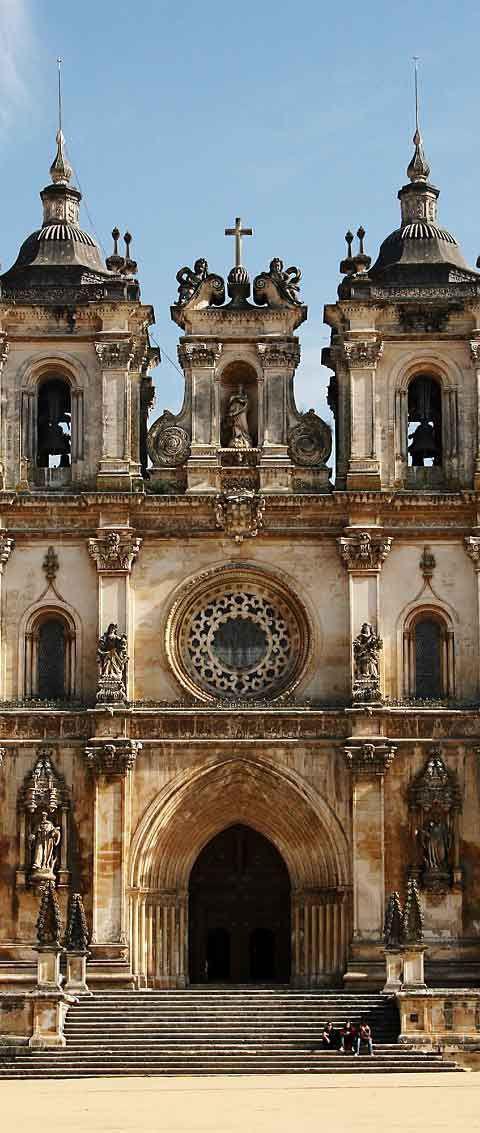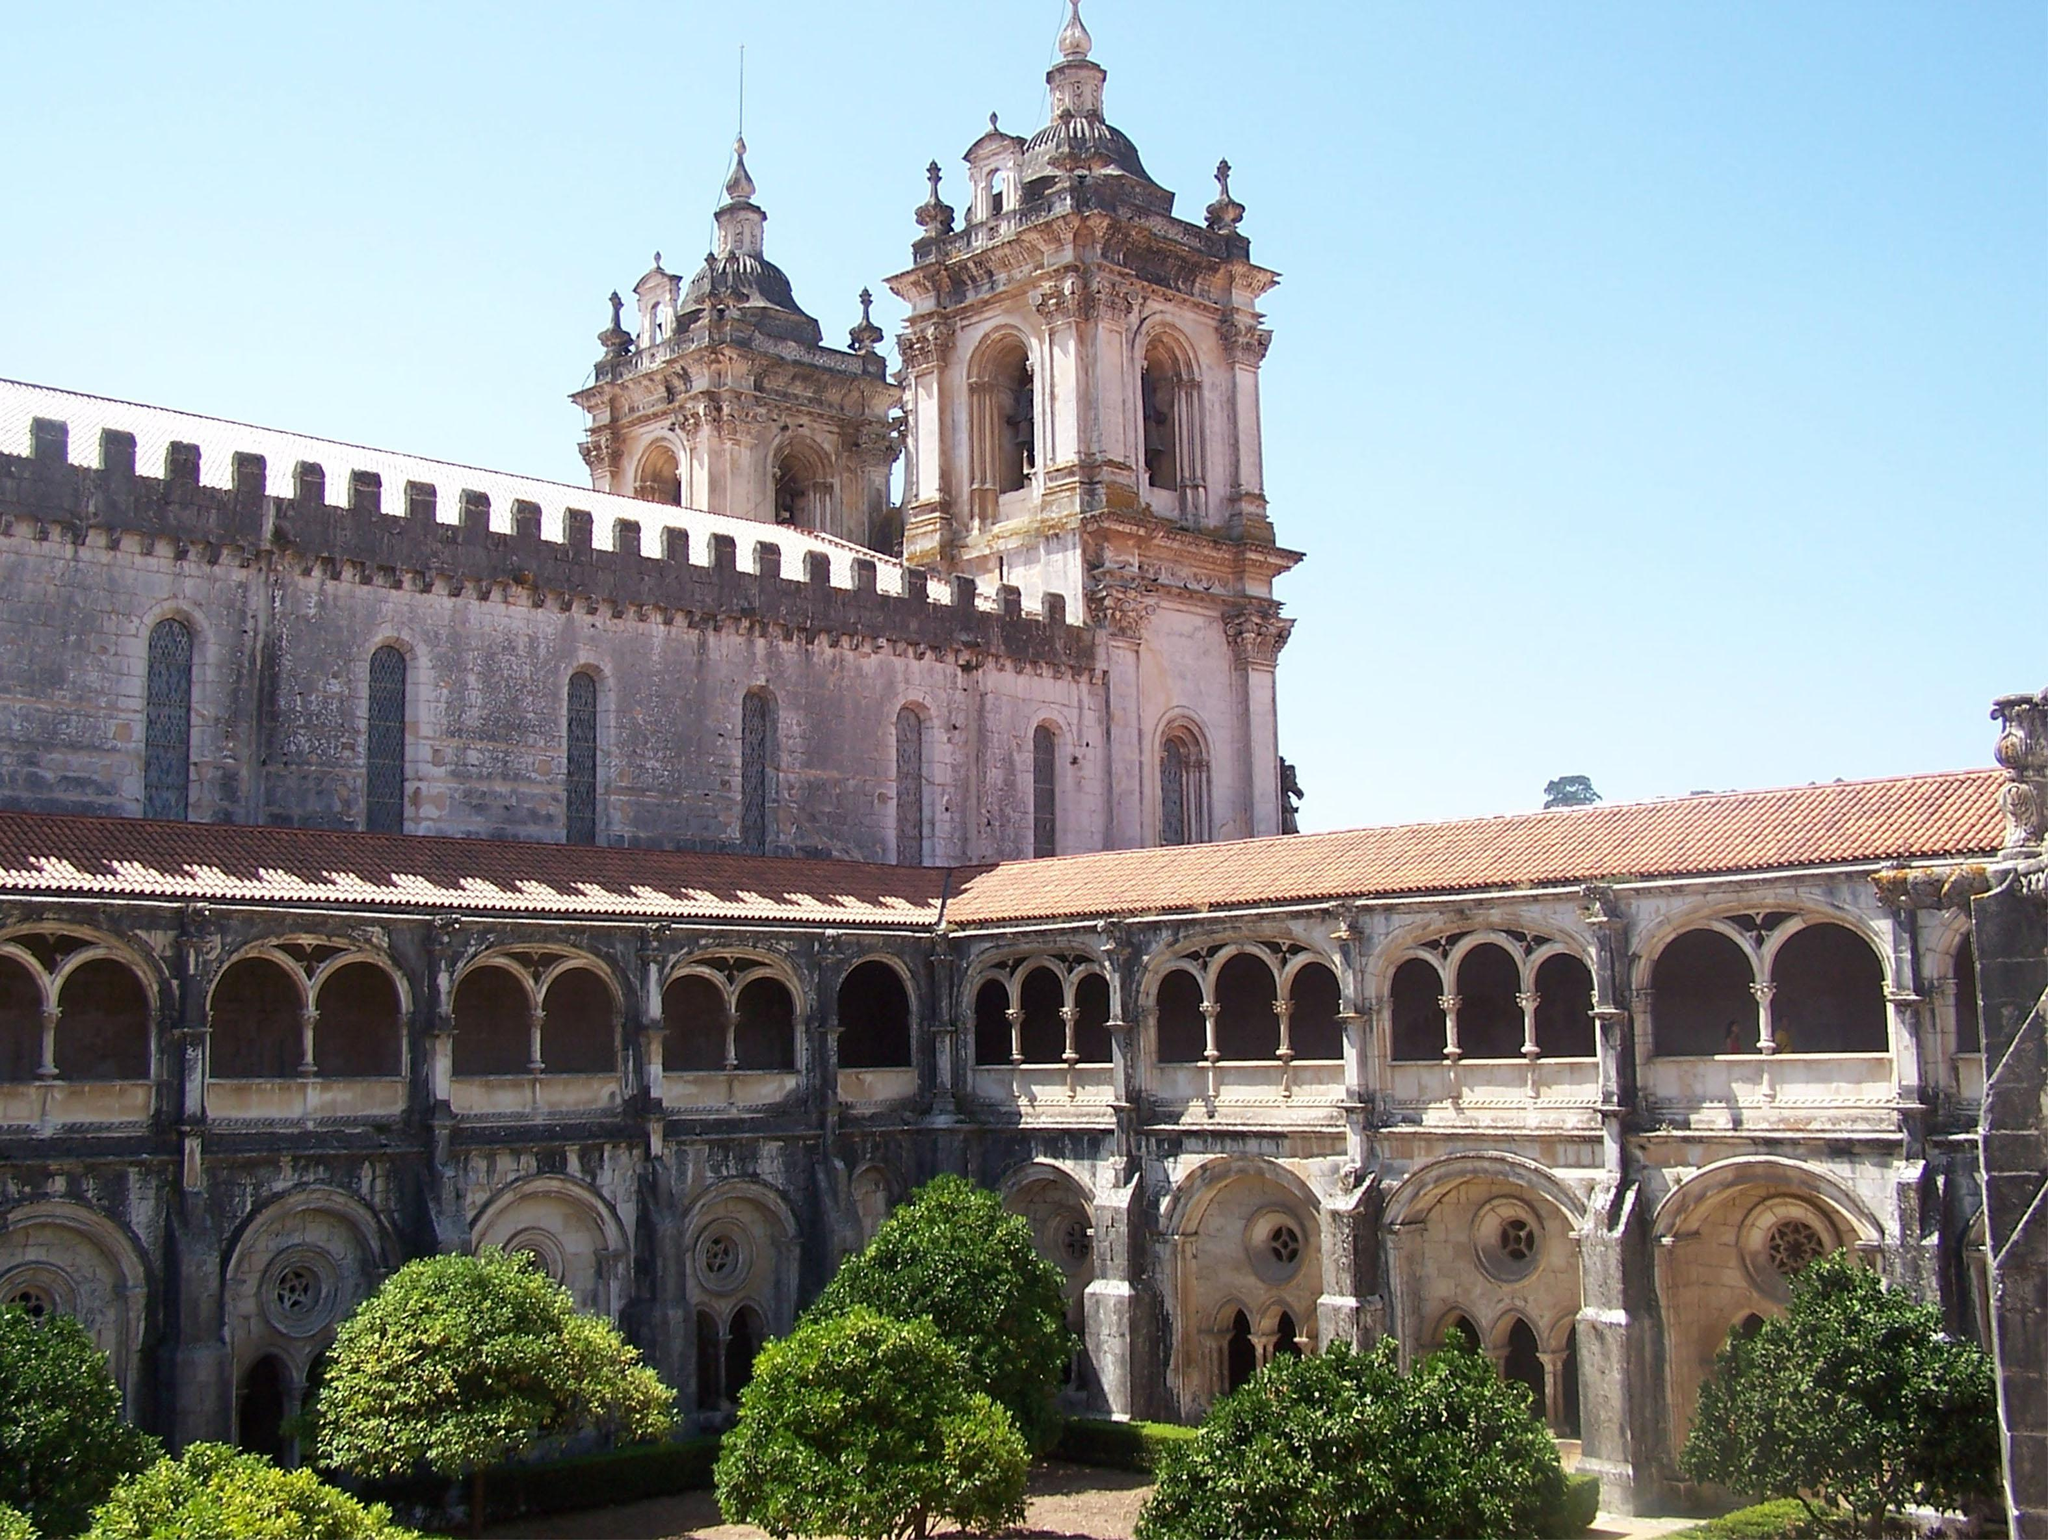The first image is the image on the left, the second image is the image on the right. For the images shown, is this caption "Each image has people on the steps in front of the building." true? Answer yes or no. No. The first image is the image on the left, the second image is the image on the right. Examine the images to the left and right. Is the description "Both buildings share the same design." accurate? Answer yes or no. No. 